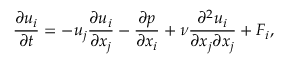<formula> <loc_0><loc_0><loc_500><loc_500>\frac { \partial u _ { i } } { \partial t } = - u _ { j } \frac { \partial u _ { i } } { \partial x _ { j } } - \frac { \partial p } { \partial x _ { i } } + \nu \frac { \partial ^ { 2 } u _ { i } } { \partial x _ { j } \partial x _ { j } } + F _ { i } ,</formula> 